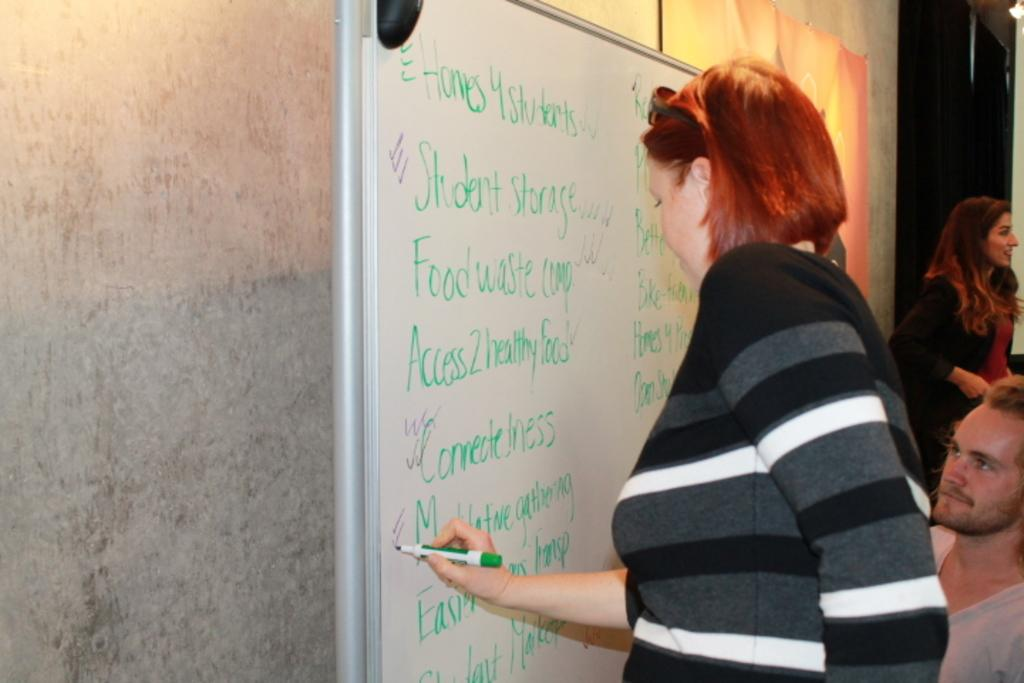Provide a one-sentence caption for the provided image. A woman writes on a board with the upper left word that reads, "homes.". 